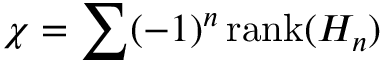<formula> <loc_0><loc_0><loc_500><loc_500>\chi = \sum ( - 1 ) ^ { n } \, r a n k ( H _ { n } )</formula> 